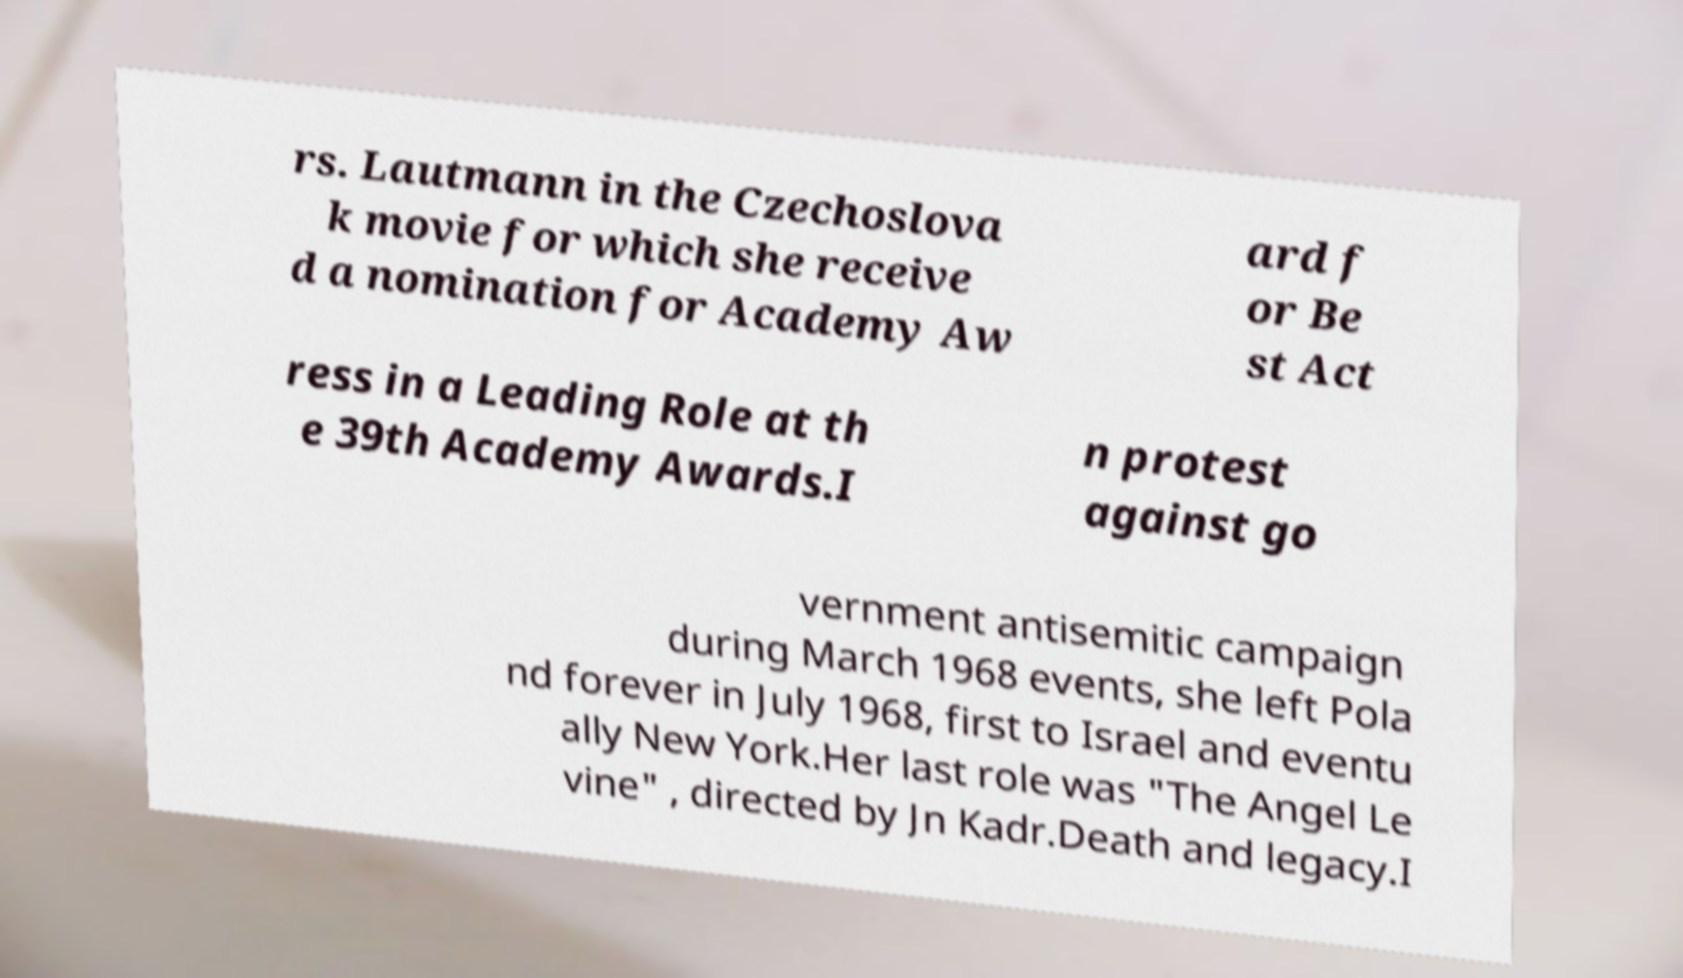I need the written content from this picture converted into text. Can you do that? rs. Lautmann in the Czechoslova k movie for which she receive d a nomination for Academy Aw ard f or Be st Act ress in a Leading Role at th e 39th Academy Awards.I n protest against go vernment antisemitic campaign during March 1968 events, she left Pola nd forever in July 1968, first to Israel and eventu ally New York.Her last role was "The Angel Le vine" , directed by Jn Kadr.Death and legacy.I 